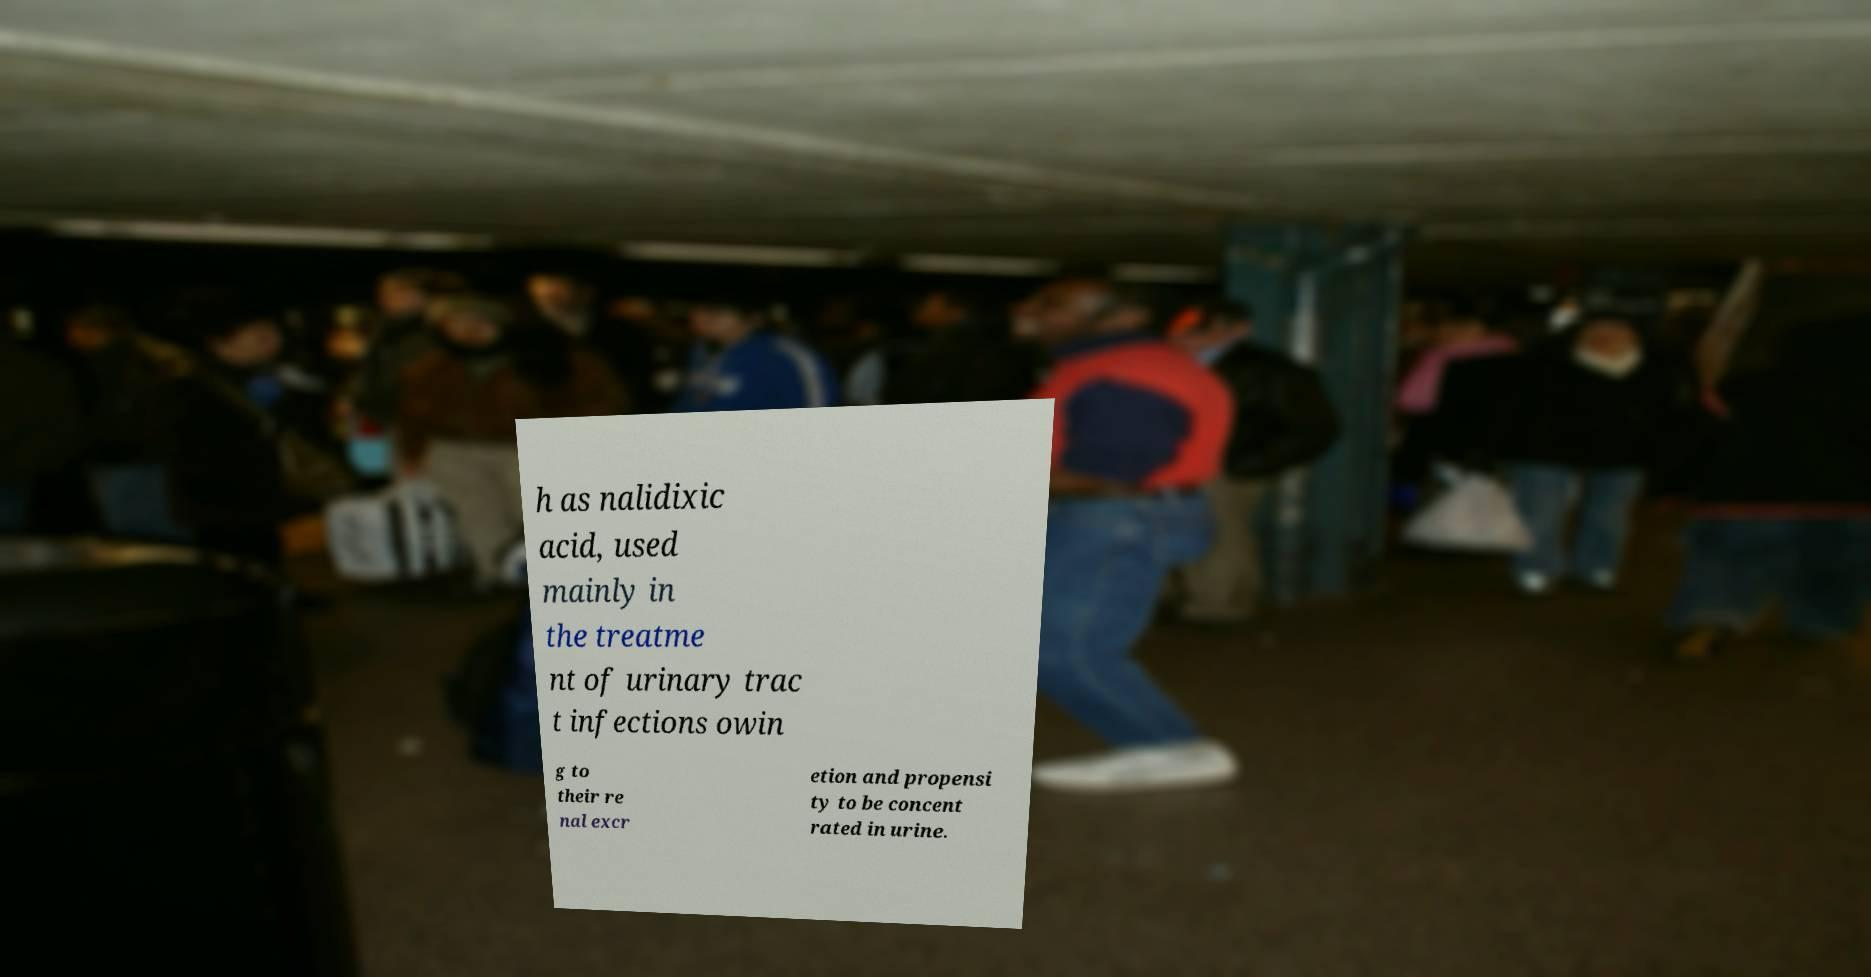Can you accurately transcribe the text from the provided image for me? h as nalidixic acid, used mainly in the treatme nt of urinary trac t infections owin g to their re nal excr etion and propensi ty to be concent rated in urine. 